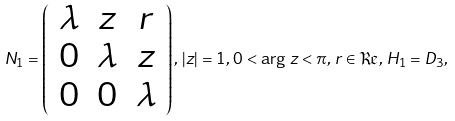Convert formula to latex. <formula><loc_0><loc_0><loc_500><loc_500>N _ { 1 } = \left ( \begin{array} { c c c } \lambda & z & r \\ 0 & \lambda & z \\ 0 & 0 & \lambda \end{array} \right ) , \, | z | = 1 , \, 0 < \arg \, z < \pi , \, r \in \Re , \, H _ { 1 } = D _ { 3 } ,</formula> 